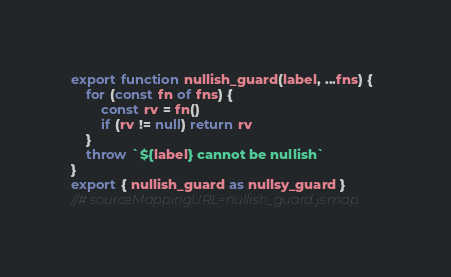<code> <loc_0><loc_0><loc_500><loc_500><_JavaScript_>export function nullish_guard(label, ...fns) {
	for (const fn of fns) {
		const rv = fn()
		if (rv != null) return rv
	}
	throw `${label} cannot be nullish`
}
export { nullish_guard as nullsy_guard }
//# sourceMappingURL=nullish_guard.js.map</code> 